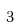<formula> <loc_0><loc_0><loc_500><loc_500>3</formula> 